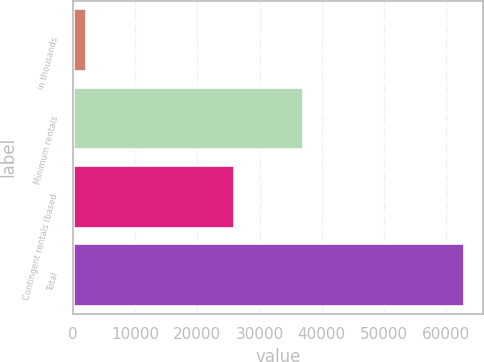Convert chart to OTSL. <chart><loc_0><loc_0><loc_500><loc_500><bar_chart><fcel>in thousands<fcel>Minimum rentals<fcel>Contingent rentals (based<fcel>Total<nl><fcel>2009<fcel>36976<fcel>25846<fcel>62822<nl></chart> 